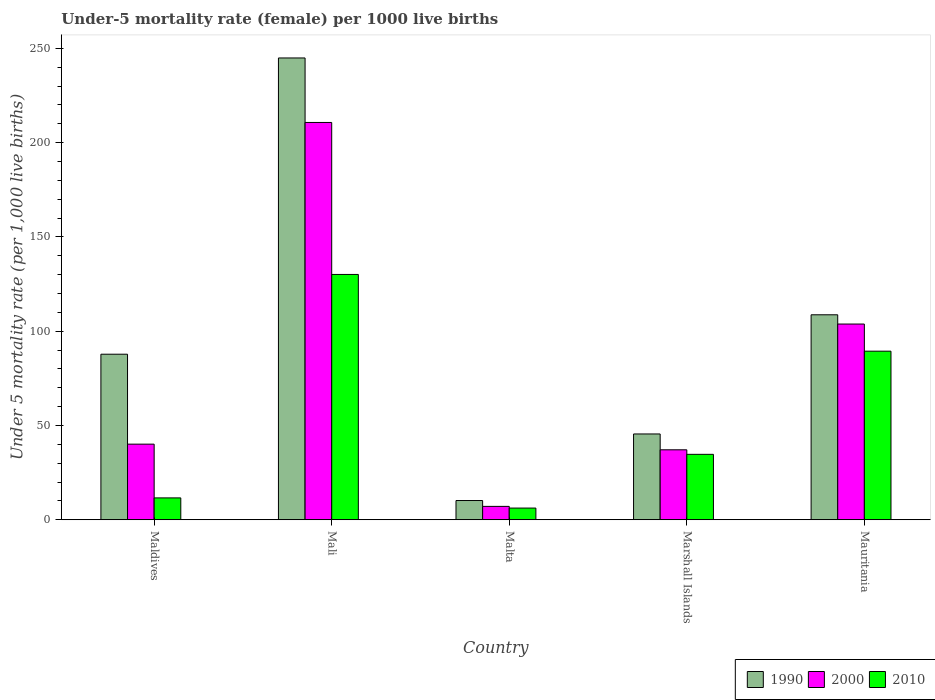How many different coloured bars are there?
Keep it short and to the point. 3. How many groups of bars are there?
Offer a very short reply. 5. Are the number of bars on each tick of the X-axis equal?
Ensure brevity in your answer.  Yes. How many bars are there on the 3rd tick from the right?
Provide a short and direct response. 3. What is the label of the 1st group of bars from the left?
Offer a terse response. Maldives. What is the under-five mortality rate in 1990 in Marshall Islands?
Your response must be concise. 45.5. Across all countries, what is the maximum under-five mortality rate in 1990?
Your response must be concise. 244.9. Across all countries, what is the minimum under-five mortality rate in 1990?
Your answer should be very brief. 10.2. In which country was the under-five mortality rate in 2010 maximum?
Provide a short and direct response. Mali. In which country was the under-five mortality rate in 2010 minimum?
Offer a terse response. Malta. What is the total under-five mortality rate in 2010 in the graph?
Provide a succinct answer. 272. What is the difference between the under-five mortality rate in 2000 in Mali and that in Malta?
Offer a terse response. 203.6. What is the difference between the under-five mortality rate in 2010 in Marshall Islands and the under-five mortality rate in 2000 in Mali?
Give a very brief answer. -176. What is the average under-five mortality rate in 1990 per country?
Offer a very short reply. 99.42. What is the difference between the under-five mortality rate of/in 2010 and under-five mortality rate of/in 1990 in Mali?
Keep it short and to the point. -114.8. What is the ratio of the under-five mortality rate in 2000 in Maldives to that in Malta?
Ensure brevity in your answer.  5.65. Is the difference between the under-five mortality rate in 2010 in Maldives and Mauritania greater than the difference between the under-five mortality rate in 1990 in Maldives and Mauritania?
Provide a short and direct response. No. What is the difference between the highest and the second highest under-five mortality rate in 1990?
Offer a very short reply. -136.2. What is the difference between the highest and the lowest under-five mortality rate in 2010?
Provide a succinct answer. 123.9. Is the sum of the under-five mortality rate in 2000 in Maldives and Mali greater than the maximum under-five mortality rate in 2010 across all countries?
Your answer should be compact. Yes. What does the 3rd bar from the left in Maldives represents?
Your answer should be compact. 2010. What does the 2nd bar from the right in Mali represents?
Provide a short and direct response. 2000. Is it the case that in every country, the sum of the under-five mortality rate in 2000 and under-five mortality rate in 2010 is greater than the under-five mortality rate in 1990?
Give a very brief answer. No. How many bars are there?
Provide a succinct answer. 15. Are the values on the major ticks of Y-axis written in scientific E-notation?
Offer a terse response. No. Does the graph contain any zero values?
Your answer should be very brief. No. Where does the legend appear in the graph?
Offer a terse response. Bottom right. How many legend labels are there?
Give a very brief answer. 3. How are the legend labels stacked?
Keep it short and to the point. Horizontal. What is the title of the graph?
Your answer should be very brief. Under-5 mortality rate (female) per 1000 live births. What is the label or title of the Y-axis?
Give a very brief answer. Under 5 mortality rate (per 1,0 live births). What is the Under 5 mortality rate (per 1,000 live births) in 1990 in Maldives?
Your answer should be compact. 87.8. What is the Under 5 mortality rate (per 1,000 live births) in 2000 in Maldives?
Offer a very short reply. 40.1. What is the Under 5 mortality rate (per 1,000 live births) of 2010 in Maldives?
Your response must be concise. 11.6. What is the Under 5 mortality rate (per 1,000 live births) of 1990 in Mali?
Offer a terse response. 244.9. What is the Under 5 mortality rate (per 1,000 live births) of 2000 in Mali?
Make the answer very short. 210.7. What is the Under 5 mortality rate (per 1,000 live births) in 2010 in Mali?
Offer a terse response. 130.1. What is the Under 5 mortality rate (per 1,000 live births) in 2000 in Malta?
Give a very brief answer. 7.1. What is the Under 5 mortality rate (per 1,000 live births) of 1990 in Marshall Islands?
Make the answer very short. 45.5. What is the Under 5 mortality rate (per 1,000 live births) in 2000 in Marshall Islands?
Your answer should be very brief. 37.1. What is the Under 5 mortality rate (per 1,000 live births) of 2010 in Marshall Islands?
Keep it short and to the point. 34.7. What is the Under 5 mortality rate (per 1,000 live births) of 1990 in Mauritania?
Make the answer very short. 108.7. What is the Under 5 mortality rate (per 1,000 live births) in 2000 in Mauritania?
Provide a succinct answer. 103.8. What is the Under 5 mortality rate (per 1,000 live births) in 2010 in Mauritania?
Provide a short and direct response. 89.4. Across all countries, what is the maximum Under 5 mortality rate (per 1,000 live births) in 1990?
Provide a succinct answer. 244.9. Across all countries, what is the maximum Under 5 mortality rate (per 1,000 live births) in 2000?
Your response must be concise. 210.7. Across all countries, what is the maximum Under 5 mortality rate (per 1,000 live births) in 2010?
Offer a terse response. 130.1. What is the total Under 5 mortality rate (per 1,000 live births) in 1990 in the graph?
Give a very brief answer. 497.1. What is the total Under 5 mortality rate (per 1,000 live births) in 2000 in the graph?
Offer a very short reply. 398.8. What is the total Under 5 mortality rate (per 1,000 live births) in 2010 in the graph?
Offer a terse response. 272. What is the difference between the Under 5 mortality rate (per 1,000 live births) in 1990 in Maldives and that in Mali?
Keep it short and to the point. -157.1. What is the difference between the Under 5 mortality rate (per 1,000 live births) in 2000 in Maldives and that in Mali?
Offer a terse response. -170.6. What is the difference between the Under 5 mortality rate (per 1,000 live births) of 2010 in Maldives and that in Mali?
Offer a very short reply. -118.5. What is the difference between the Under 5 mortality rate (per 1,000 live births) in 1990 in Maldives and that in Malta?
Provide a succinct answer. 77.6. What is the difference between the Under 5 mortality rate (per 1,000 live births) in 2000 in Maldives and that in Malta?
Give a very brief answer. 33. What is the difference between the Under 5 mortality rate (per 1,000 live births) of 1990 in Maldives and that in Marshall Islands?
Offer a very short reply. 42.3. What is the difference between the Under 5 mortality rate (per 1,000 live births) of 2000 in Maldives and that in Marshall Islands?
Ensure brevity in your answer.  3. What is the difference between the Under 5 mortality rate (per 1,000 live births) of 2010 in Maldives and that in Marshall Islands?
Your answer should be compact. -23.1. What is the difference between the Under 5 mortality rate (per 1,000 live births) in 1990 in Maldives and that in Mauritania?
Give a very brief answer. -20.9. What is the difference between the Under 5 mortality rate (per 1,000 live births) of 2000 in Maldives and that in Mauritania?
Give a very brief answer. -63.7. What is the difference between the Under 5 mortality rate (per 1,000 live births) of 2010 in Maldives and that in Mauritania?
Your response must be concise. -77.8. What is the difference between the Under 5 mortality rate (per 1,000 live births) of 1990 in Mali and that in Malta?
Offer a very short reply. 234.7. What is the difference between the Under 5 mortality rate (per 1,000 live births) in 2000 in Mali and that in Malta?
Your response must be concise. 203.6. What is the difference between the Under 5 mortality rate (per 1,000 live births) of 2010 in Mali and that in Malta?
Offer a terse response. 123.9. What is the difference between the Under 5 mortality rate (per 1,000 live births) in 1990 in Mali and that in Marshall Islands?
Your answer should be compact. 199.4. What is the difference between the Under 5 mortality rate (per 1,000 live births) of 2000 in Mali and that in Marshall Islands?
Offer a terse response. 173.6. What is the difference between the Under 5 mortality rate (per 1,000 live births) of 2010 in Mali and that in Marshall Islands?
Offer a terse response. 95.4. What is the difference between the Under 5 mortality rate (per 1,000 live births) of 1990 in Mali and that in Mauritania?
Your answer should be very brief. 136.2. What is the difference between the Under 5 mortality rate (per 1,000 live births) of 2000 in Mali and that in Mauritania?
Offer a terse response. 106.9. What is the difference between the Under 5 mortality rate (per 1,000 live births) in 2010 in Mali and that in Mauritania?
Your answer should be very brief. 40.7. What is the difference between the Under 5 mortality rate (per 1,000 live births) of 1990 in Malta and that in Marshall Islands?
Offer a very short reply. -35.3. What is the difference between the Under 5 mortality rate (per 1,000 live births) in 2010 in Malta and that in Marshall Islands?
Offer a terse response. -28.5. What is the difference between the Under 5 mortality rate (per 1,000 live births) of 1990 in Malta and that in Mauritania?
Keep it short and to the point. -98.5. What is the difference between the Under 5 mortality rate (per 1,000 live births) of 2000 in Malta and that in Mauritania?
Offer a terse response. -96.7. What is the difference between the Under 5 mortality rate (per 1,000 live births) in 2010 in Malta and that in Mauritania?
Offer a terse response. -83.2. What is the difference between the Under 5 mortality rate (per 1,000 live births) in 1990 in Marshall Islands and that in Mauritania?
Ensure brevity in your answer.  -63.2. What is the difference between the Under 5 mortality rate (per 1,000 live births) in 2000 in Marshall Islands and that in Mauritania?
Ensure brevity in your answer.  -66.7. What is the difference between the Under 5 mortality rate (per 1,000 live births) in 2010 in Marshall Islands and that in Mauritania?
Provide a succinct answer. -54.7. What is the difference between the Under 5 mortality rate (per 1,000 live births) in 1990 in Maldives and the Under 5 mortality rate (per 1,000 live births) in 2000 in Mali?
Your answer should be compact. -122.9. What is the difference between the Under 5 mortality rate (per 1,000 live births) of 1990 in Maldives and the Under 5 mortality rate (per 1,000 live births) of 2010 in Mali?
Offer a terse response. -42.3. What is the difference between the Under 5 mortality rate (per 1,000 live births) in 2000 in Maldives and the Under 5 mortality rate (per 1,000 live births) in 2010 in Mali?
Offer a terse response. -90. What is the difference between the Under 5 mortality rate (per 1,000 live births) in 1990 in Maldives and the Under 5 mortality rate (per 1,000 live births) in 2000 in Malta?
Keep it short and to the point. 80.7. What is the difference between the Under 5 mortality rate (per 1,000 live births) in 1990 in Maldives and the Under 5 mortality rate (per 1,000 live births) in 2010 in Malta?
Your response must be concise. 81.6. What is the difference between the Under 5 mortality rate (per 1,000 live births) of 2000 in Maldives and the Under 5 mortality rate (per 1,000 live births) of 2010 in Malta?
Keep it short and to the point. 33.9. What is the difference between the Under 5 mortality rate (per 1,000 live births) of 1990 in Maldives and the Under 5 mortality rate (per 1,000 live births) of 2000 in Marshall Islands?
Provide a succinct answer. 50.7. What is the difference between the Under 5 mortality rate (per 1,000 live births) of 1990 in Maldives and the Under 5 mortality rate (per 1,000 live births) of 2010 in Marshall Islands?
Your answer should be very brief. 53.1. What is the difference between the Under 5 mortality rate (per 1,000 live births) in 2000 in Maldives and the Under 5 mortality rate (per 1,000 live births) in 2010 in Marshall Islands?
Provide a short and direct response. 5.4. What is the difference between the Under 5 mortality rate (per 1,000 live births) in 1990 in Maldives and the Under 5 mortality rate (per 1,000 live births) in 2000 in Mauritania?
Your answer should be compact. -16. What is the difference between the Under 5 mortality rate (per 1,000 live births) in 2000 in Maldives and the Under 5 mortality rate (per 1,000 live births) in 2010 in Mauritania?
Your response must be concise. -49.3. What is the difference between the Under 5 mortality rate (per 1,000 live births) in 1990 in Mali and the Under 5 mortality rate (per 1,000 live births) in 2000 in Malta?
Provide a short and direct response. 237.8. What is the difference between the Under 5 mortality rate (per 1,000 live births) in 1990 in Mali and the Under 5 mortality rate (per 1,000 live births) in 2010 in Malta?
Your response must be concise. 238.7. What is the difference between the Under 5 mortality rate (per 1,000 live births) of 2000 in Mali and the Under 5 mortality rate (per 1,000 live births) of 2010 in Malta?
Provide a short and direct response. 204.5. What is the difference between the Under 5 mortality rate (per 1,000 live births) in 1990 in Mali and the Under 5 mortality rate (per 1,000 live births) in 2000 in Marshall Islands?
Your answer should be compact. 207.8. What is the difference between the Under 5 mortality rate (per 1,000 live births) of 1990 in Mali and the Under 5 mortality rate (per 1,000 live births) of 2010 in Marshall Islands?
Offer a very short reply. 210.2. What is the difference between the Under 5 mortality rate (per 1,000 live births) of 2000 in Mali and the Under 5 mortality rate (per 1,000 live births) of 2010 in Marshall Islands?
Offer a terse response. 176. What is the difference between the Under 5 mortality rate (per 1,000 live births) of 1990 in Mali and the Under 5 mortality rate (per 1,000 live births) of 2000 in Mauritania?
Make the answer very short. 141.1. What is the difference between the Under 5 mortality rate (per 1,000 live births) in 1990 in Mali and the Under 5 mortality rate (per 1,000 live births) in 2010 in Mauritania?
Give a very brief answer. 155.5. What is the difference between the Under 5 mortality rate (per 1,000 live births) in 2000 in Mali and the Under 5 mortality rate (per 1,000 live births) in 2010 in Mauritania?
Your response must be concise. 121.3. What is the difference between the Under 5 mortality rate (per 1,000 live births) in 1990 in Malta and the Under 5 mortality rate (per 1,000 live births) in 2000 in Marshall Islands?
Offer a very short reply. -26.9. What is the difference between the Under 5 mortality rate (per 1,000 live births) in 1990 in Malta and the Under 5 mortality rate (per 1,000 live births) in 2010 in Marshall Islands?
Provide a succinct answer. -24.5. What is the difference between the Under 5 mortality rate (per 1,000 live births) of 2000 in Malta and the Under 5 mortality rate (per 1,000 live births) of 2010 in Marshall Islands?
Your answer should be compact. -27.6. What is the difference between the Under 5 mortality rate (per 1,000 live births) in 1990 in Malta and the Under 5 mortality rate (per 1,000 live births) in 2000 in Mauritania?
Your answer should be very brief. -93.6. What is the difference between the Under 5 mortality rate (per 1,000 live births) in 1990 in Malta and the Under 5 mortality rate (per 1,000 live births) in 2010 in Mauritania?
Give a very brief answer. -79.2. What is the difference between the Under 5 mortality rate (per 1,000 live births) in 2000 in Malta and the Under 5 mortality rate (per 1,000 live births) in 2010 in Mauritania?
Your answer should be very brief. -82.3. What is the difference between the Under 5 mortality rate (per 1,000 live births) of 1990 in Marshall Islands and the Under 5 mortality rate (per 1,000 live births) of 2000 in Mauritania?
Provide a succinct answer. -58.3. What is the difference between the Under 5 mortality rate (per 1,000 live births) of 1990 in Marshall Islands and the Under 5 mortality rate (per 1,000 live births) of 2010 in Mauritania?
Your response must be concise. -43.9. What is the difference between the Under 5 mortality rate (per 1,000 live births) in 2000 in Marshall Islands and the Under 5 mortality rate (per 1,000 live births) in 2010 in Mauritania?
Your answer should be compact. -52.3. What is the average Under 5 mortality rate (per 1,000 live births) of 1990 per country?
Make the answer very short. 99.42. What is the average Under 5 mortality rate (per 1,000 live births) of 2000 per country?
Provide a short and direct response. 79.76. What is the average Under 5 mortality rate (per 1,000 live births) in 2010 per country?
Your answer should be very brief. 54.4. What is the difference between the Under 5 mortality rate (per 1,000 live births) of 1990 and Under 5 mortality rate (per 1,000 live births) of 2000 in Maldives?
Your answer should be compact. 47.7. What is the difference between the Under 5 mortality rate (per 1,000 live births) of 1990 and Under 5 mortality rate (per 1,000 live births) of 2010 in Maldives?
Provide a succinct answer. 76.2. What is the difference between the Under 5 mortality rate (per 1,000 live births) of 1990 and Under 5 mortality rate (per 1,000 live births) of 2000 in Mali?
Your response must be concise. 34.2. What is the difference between the Under 5 mortality rate (per 1,000 live births) in 1990 and Under 5 mortality rate (per 1,000 live births) in 2010 in Mali?
Your answer should be compact. 114.8. What is the difference between the Under 5 mortality rate (per 1,000 live births) in 2000 and Under 5 mortality rate (per 1,000 live births) in 2010 in Mali?
Give a very brief answer. 80.6. What is the difference between the Under 5 mortality rate (per 1,000 live births) of 1990 and Under 5 mortality rate (per 1,000 live births) of 2000 in Malta?
Make the answer very short. 3.1. What is the difference between the Under 5 mortality rate (per 1,000 live births) in 2000 and Under 5 mortality rate (per 1,000 live births) in 2010 in Malta?
Offer a very short reply. 0.9. What is the difference between the Under 5 mortality rate (per 1,000 live births) in 1990 and Under 5 mortality rate (per 1,000 live births) in 2000 in Marshall Islands?
Offer a very short reply. 8.4. What is the difference between the Under 5 mortality rate (per 1,000 live births) of 1990 and Under 5 mortality rate (per 1,000 live births) of 2010 in Marshall Islands?
Provide a succinct answer. 10.8. What is the difference between the Under 5 mortality rate (per 1,000 live births) of 1990 and Under 5 mortality rate (per 1,000 live births) of 2000 in Mauritania?
Provide a succinct answer. 4.9. What is the difference between the Under 5 mortality rate (per 1,000 live births) of 1990 and Under 5 mortality rate (per 1,000 live births) of 2010 in Mauritania?
Offer a very short reply. 19.3. What is the ratio of the Under 5 mortality rate (per 1,000 live births) in 1990 in Maldives to that in Mali?
Your answer should be compact. 0.36. What is the ratio of the Under 5 mortality rate (per 1,000 live births) in 2000 in Maldives to that in Mali?
Ensure brevity in your answer.  0.19. What is the ratio of the Under 5 mortality rate (per 1,000 live births) in 2010 in Maldives to that in Mali?
Offer a very short reply. 0.09. What is the ratio of the Under 5 mortality rate (per 1,000 live births) in 1990 in Maldives to that in Malta?
Offer a very short reply. 8.61. What is the ratio of the Under 5 mortality rate (per 1,000 live births) of 2000 in Maldives to that in Malta?
Give a very brief answer. 5.65. What is the ratio of the Under 5 mortality rate (per 1,000 live births) in 2010 in Maldives to that in Malta?
Ensure brevity in your answer.  1.87. What is the ratio of the Under 5 mortality rate (per 1,000 live births) in 1990 in Maldives to that in Marshall Islands?
Offer a terse response. 1.93. What is the ratio of the Under 5 mortality rate (per 1,000 live births) of 2000 in Maldives to that in Marshall Islands?
Your answer should be very brief. 1.08. What is the ratio of the Under 5 mortality rate (per 1,000 live births) of 2010 in Maldives to that in Marshall Islands?
Offer a terse response. 0.33. What is the ratio of the Under 5 mortality rate (per 1,000 live births) of 1990 in Maldives to that in Mauritania?
Ensure brevity in your answer.  0.81. What is the ratio of the Under 5 mortality rate (per 1,000 live births) in 2000 in Maldives to that in Mauritania?
Give a very brief answer. 0.39. What is the ratio of the Under 5 mortality rate (per 1,000 live births) of 2010 in Maldives to that in Mauritania?
Your answer should be compact. 0.13. What is the ratio of the Under 5 mortality rate (per 1,000 live births) of 1990 in Mali to that in Malta?
Keep it short and to the point. 24.01. What is the ratio of the Under 5 mortality rate (per 1,000 live births) of 2000 in Mali to that in Malta?
Your response must be concise. 29.68. What is the ratio of the Under 5 mortality rate (per 1,000 live births) of 2010 in Mali to that in Malta?
Your answer should be compact. 20.98. What is the ratio of the Under 5 mortality rate (per 1,000 live births) in 1990 in Mali to that in Marshall Islands?
Ensure brevity in your answer.  5.38. What is the ratio of the Under 5 mortality rate (per 1,000 live births) in 2000 in Mali to that in Marshall Islands?
Provide a succinct answer. 5.68. What is the ratio of the Under 5 mortality rate (per 1,000 live births) of 2010 in Mali to that in Marshall Islands?
Offer a very short reply. 3.75. What is the ratio of the Under 5 mortality rate (per 1,000 live births) in 1990 in Mali to that in Mauritania?
Your answer should be very brief. 2.25. What is the ratio of the Under 5 mortality rate (per 1,000 live births) in 2000 in Mali to that in Mauritania?
Keep it short and to the point. 2.03. What is the ratio of the Under 5 mortality rate (per 1,000 live births) of 2010 in Mali to that in Mauritania?
Make the answer very short. 1.46. What is the ratio of the Under 5 mortality rate (per 1,000 live births) in 1990 in Malta to that in Marshall Islands?
Provide a succinct answer. 0.22. What is the ratio of the Under 5 mortality rate (per 1,000 live births) in 2000 in Malta to that in Marshall Islands?
Your answer should be compact. 0.19. What is the ratio of the Under 5 mortality rate (per 1,000 live births) of 2010 in Malta to that in Marshall Islands?
Make the answer very short. 0.18. What is the ratio of the Under 5 mortality rate (per 1,000 live births) of 1990 in Malta to that in Mauritania?
Your response must be concise. 0.09. What is the ratio of the Under 5 mortality rate (per 1,000 live births) in 2000 in Malta to that in Mauritania?
Provide a succinct answer. 0.07. What is the ratio of the Under 5 mortality rate (per 1,000 live births) in 2010 in Malta to that in Mauritania?
Your answer should be compact. 0.07. What is the ratio of the Under 5 mortality rate (per 1,000 live births) in 1990 in Marshall Islands to that in Mauritania?
Make the answer very short. 0.42. What is the ratio of the Under 5 mortality rate (per 1,000 live births) in 2000 in Marshall Islands to that in Mauritania?
Provide a short and direct response. 0.36. What is the ratio of the Under 5 mortality rate (per 1,000 live births) in 2010 in Marshall Islands to that in Mauritania?
Ensure brevity in your answer.  0.39. What is the difference between the highest and the second highest Under 5 mortality rate (per 1,000 live births) of 1990?
Your response must be concise. 136.2. What is the difference between the highest and the second highest Under 5 mortality rate (per 1,000 live births) in 2000?
Your response must be concise. 106.9. What is the difference between the highest and the second highest Under 5 mortality rate (per 1,000 live births) of 2010?
Provide a short and direct response. 40.7. What is the difference between the highest and the lowest Under 5 mortality rate (per 1,000 live births) of 1990?
Give a very brief answer. 234.7. What is the difference between the highest and the lowest Under 5 mortality rate (per 1,000 live births) of 2000?
Offer a very short reply. 203.6. What is the difference between the highest and the lowest Under 5 mortality rate (per 1,000 live births) of 2010?
Provide a short and direct response. 123.9. 